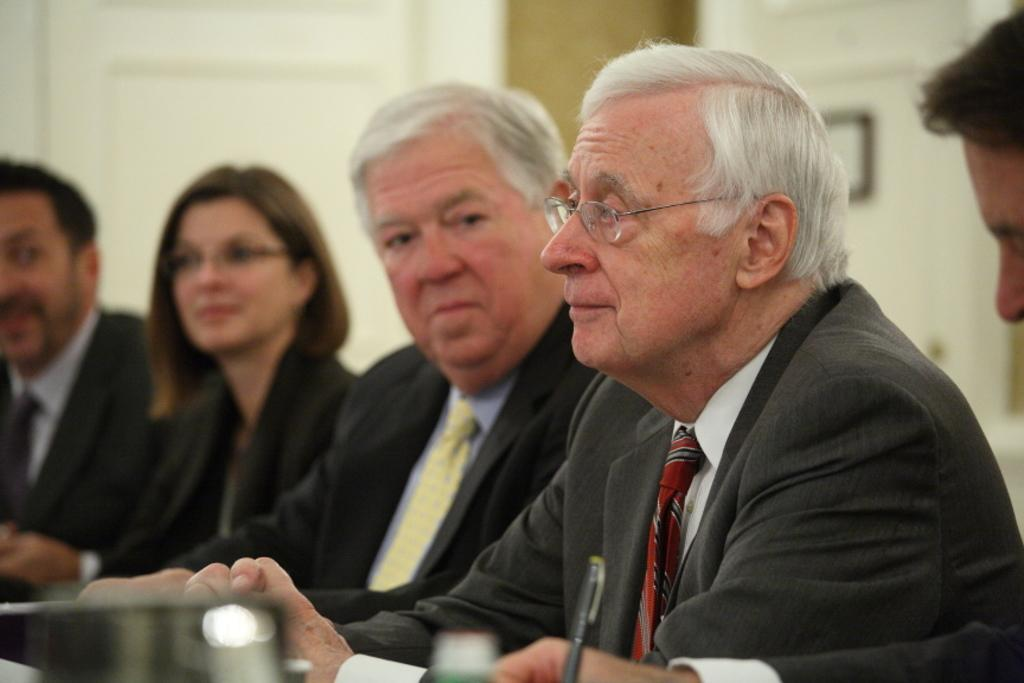What are the people in the image doing? The people in the image are sitting. What are the people wearing? The people are wearing clothes. Can you describe any specific accessories worn by the people? Two of the people are wearing spectacles. What object can be seen in the image that might be used for writing? There is a pen visible in the image. How would you describe the background of the image? The background of the image is slightly blurred. What type of salt is being used in the song that is playing in the image? There is no mention of salt or a song playing in the image; it primarily features people sitting and wearing clothes. 